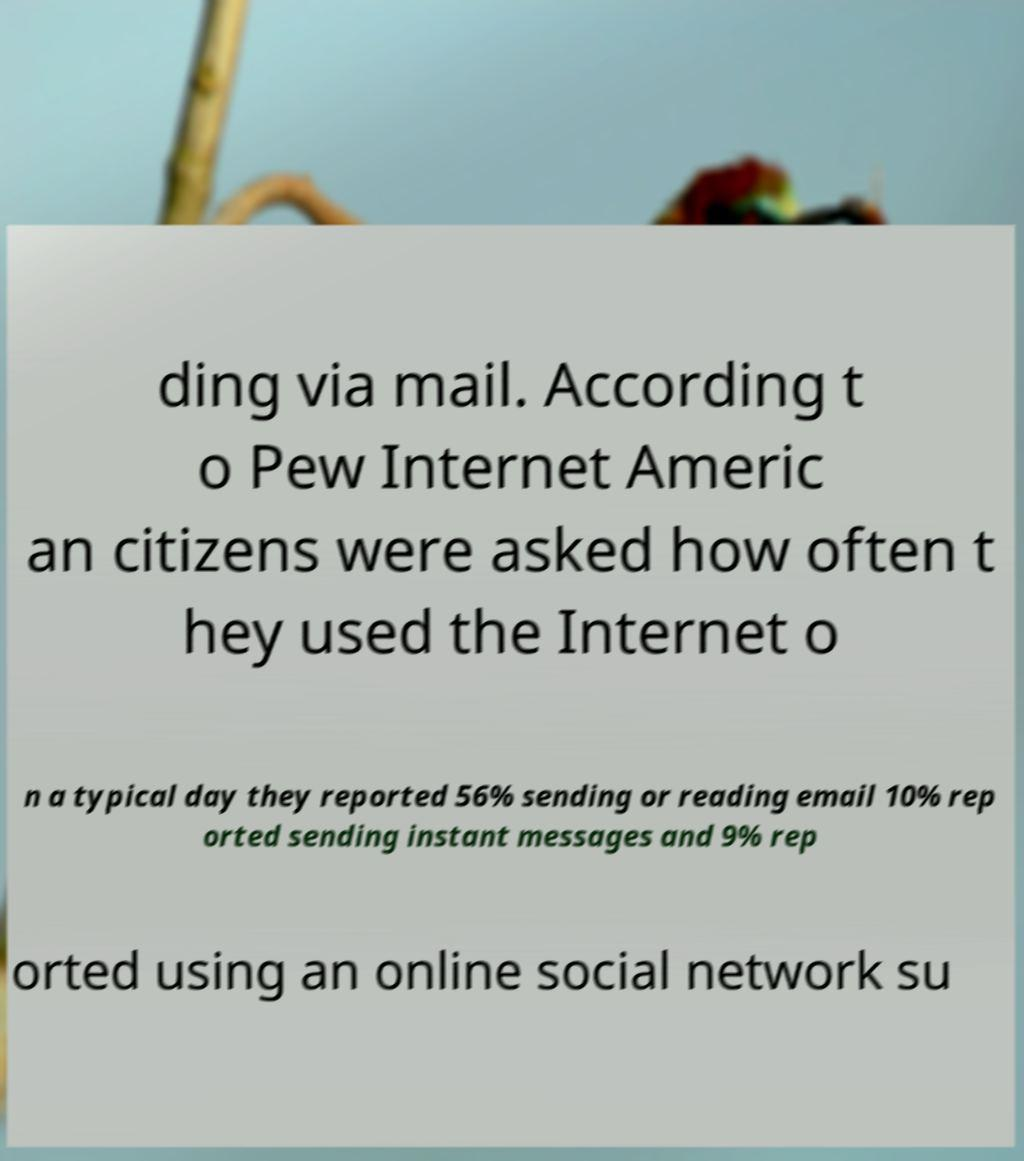What messages or text are displayed in this image? I need them in a readable, typed format. ding via mail. According t o Pew Internet Americ an citizens were asked how often t hey used the Internet o n a typical day they reported 56% sending or reading email 10% rep orted sending instant messages and 9% rep orted using an online social network su 